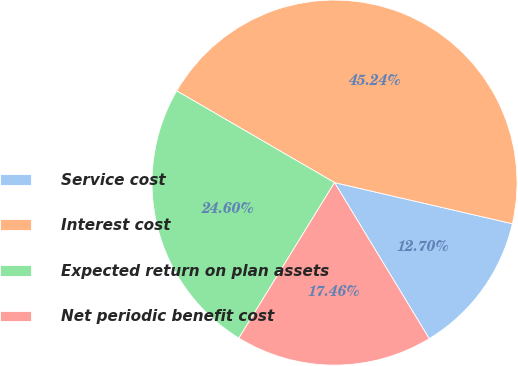<chart> <loc_0><loc_0><loc_500><loc_500><pie_chart><fcel>Service cost<fcel>Interest cost<fcel>Expected return on plan assets<fcel>Net periodic benefit cost<nl><fcel>12.7%<fcel>45.24%<fcel>24.6%<fcel>17.46%<nl></chart> 